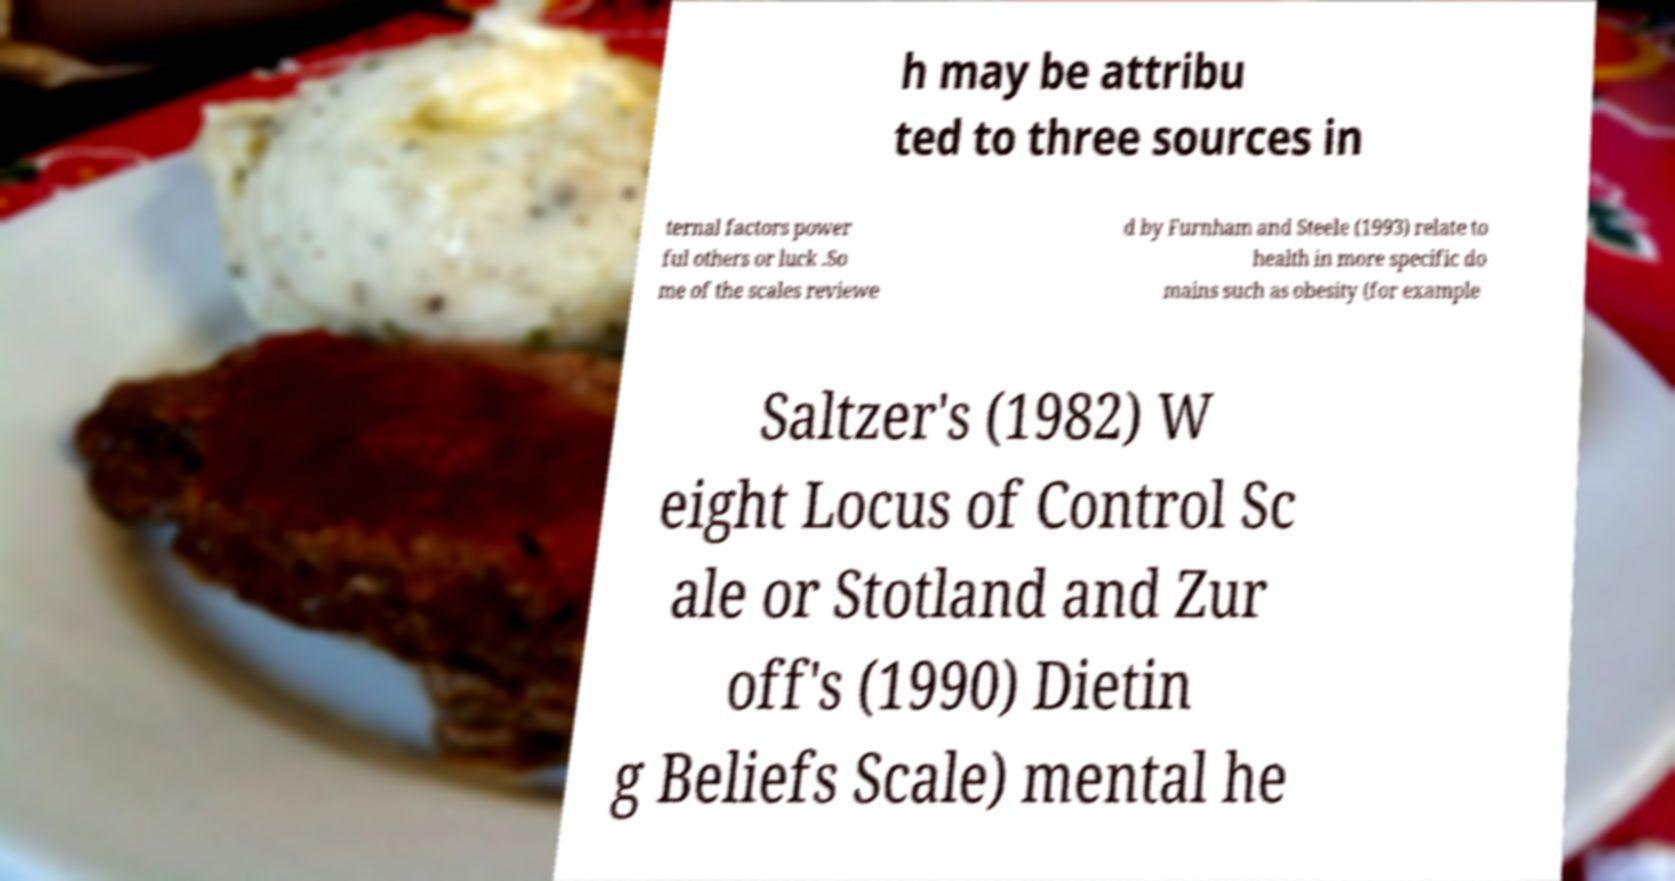Can you read and provide the text displayed in the image?This photo seems to have some interesting text. Can you extract and type it out for me? h may be attribu ted to three sources in ternal factors power ful others or luck .So me of the scales reviewe d by Furnham and Steele (1993) relate to health in more specific do mains such as obesity (for example Saltzer's (1982) W eight Locus of Control Sc ale or Stotland and Zur off's (1990) Dietin g Beliefs Scale) mental he 